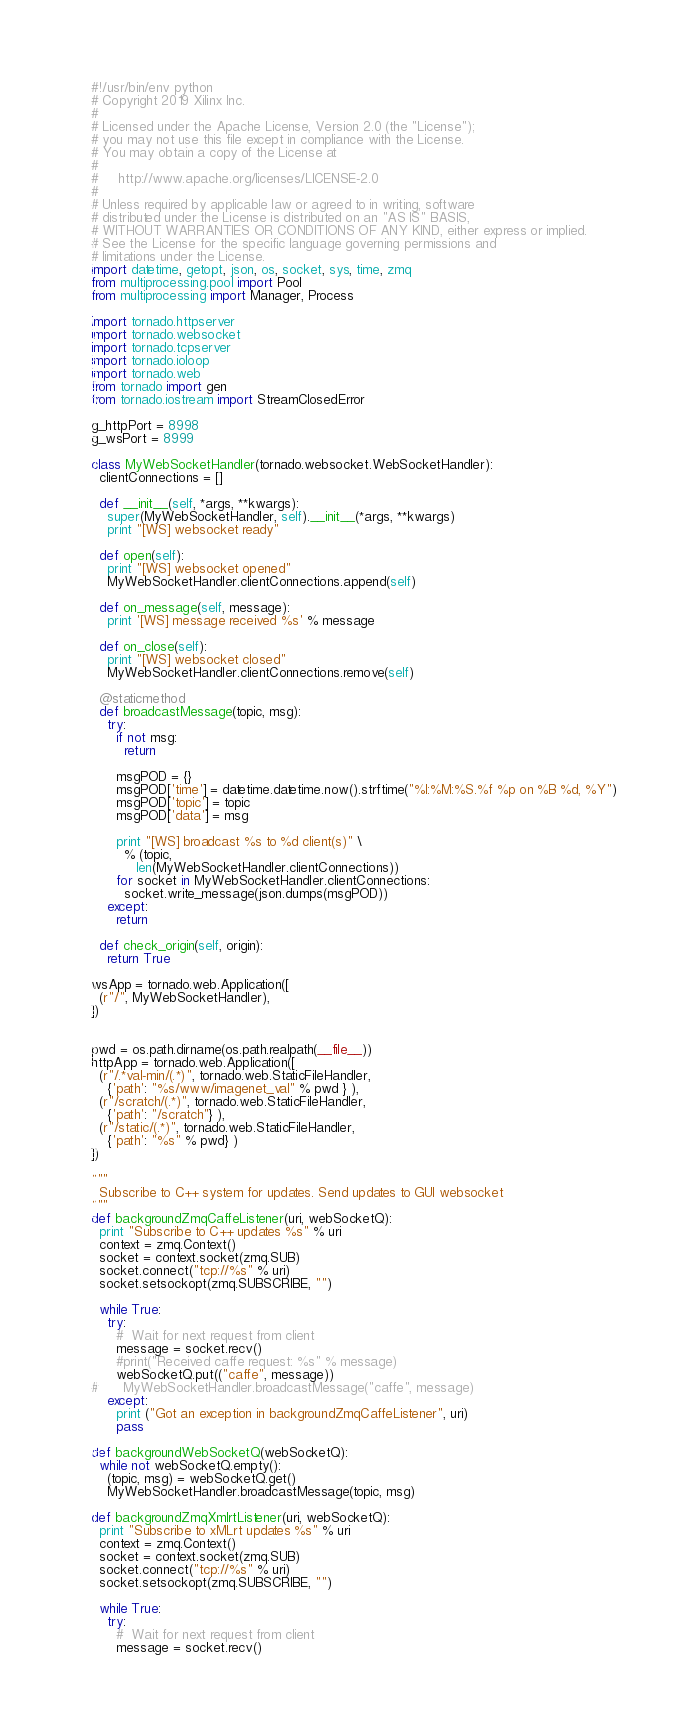<code> <loc_0><loc_0><loc_500><loc_500><_Python_>#!/usr/bin/env python
# Copyright 2019 Xilinx Inc.
#
# Licensed under the Apache License, Version 2.0 (the "License");
# you may not use this file except in compliance with the License.
# You may obtain a copy of the License at
#
#     http://www.apache.org/licenses/LICENSE-2.0
#
# Unless required by applicable law or agreed to in writing, software
# distributed under the License is distributed on an "AS IS" BASIS,
# WITHOUT WARRANTIES OR CONDITIONS OF ANY KIND, either express or implied.
# See the License for the specific language governing permissions and
# limitations under the License.
import datetime, getopt, json, os, socket, sys, time, zmq
from multiprocessing.pool import Pool
from multiprocessing import Manager, Process

import tornado.httpserver
import tornado.websocket
import tornado.tcpserver
import tornado.ioloop
import tornado.web
from tornado import gen
from tornado.iostream import StreamClosedError

g_httpPort = 8998
g_wsPort = 8999

class MyWebSocketHandler(tornado.websocket.WebSocketHandler):
  clientConnections = []

  def __init__(self, *args, **kwargs):
    super(MyWebSocketHandler, self).__init__(*args, **kwargs)
    print "[WS] websocket ready"

  def open(self):
    print "[WS] websocket opened"
    MyWebSocketHandler.clientConnections.append(self)

  def on_message(self, message):
    print '[WS] message received %s' % message

  def on_close(self):
    print "[WS] websocket closed"
    MyWebSocketHandler.clientConnections.remove(self)

  @staticmethod
  def broadcastMessage(topic, msg):
    try:
      if not msg:
        return

      msgPOD = {}
      msgPOD['time'] = datetime.datetime.now().strftime("%I:%M:%S.%f %p on %B %d, %Y")
      msgPOD['topic'] = topic
      msgPOD['data'] = msg

      print "[WS] broadcast %s to %d client(s)" \
        % (topic,
           len(MyWebSocketHandler.clientConnections))
      for socket in MyWebSocketHandler.clientConnections:
        socket.write_message(json.dumps(msgPOD))
    except:
      return

  def check_origin(self, origin):
    return True

wsApp = tornado.web.Application([
  (r"/", MyWebSocketHandler),
])


pwd = os.path.dirname(os.path.realpath(__file__))
httpApp = tornado.web.Application([
  (r"/.*val-min/(.*)", tornado.web.StaticFileHandler,
    {'path': "%s/www/imagenet_val" % pwd } ),
  (r"/scratch/(.*)", tornado.web.StaticFileHandler,
    {'path': "/scratch"} ),
  (r"/static/(.*)", tornado.web.StaticFileHandler,
    {'path': "%s" % pwd} )
])

"""
  Subscribe to C++ system for updates. Send updates to GUI websocket
"""
def backgroundZmqCaffeListener(uri, webSocketQ):
  print "Subscribe to C++ updates %s" % uri
  context = zmq.Context()
  socket = context.socket(zmq.SUB)
  socket.connect("tcp://%s" % uri)
  socket.setsockopt(zmq.SUBSCRIBE, "")

  while True:
    try:
      #  Wait for next request from client
      message = socket.recv()
      #print("Received caffe request: %s" % message)
      webSocketQ.put(("caffe", message))
#      MyWebSocketHandler.broadcastMessage("caffe", message)
    except:
      print ("Got an exception in backgroundZmqCaffeListener", uri)
      pass

def backgroundWebSocketQ(webSocketQ):
  while not webSocketQ.empty():
    (topic, msg) = webSocketQ.get()
    MyWebSocketHandler.broadcastMessage(topic, msg)

def backgroundZmqXmlrtListener(uri, webSocketQ):
  print "Subscribe to xMLrt updates %s" % uri
  context = zmq.Context()
  socket = context.socket(zmq.SUB)
  socket.connect("tcp://%s" % uri)
  socket.setsockopt(zmq.SUBSCRIBE, "")

  while True:
    try:
      #  Wait for next request from client
      message = socket.recv()</code> 